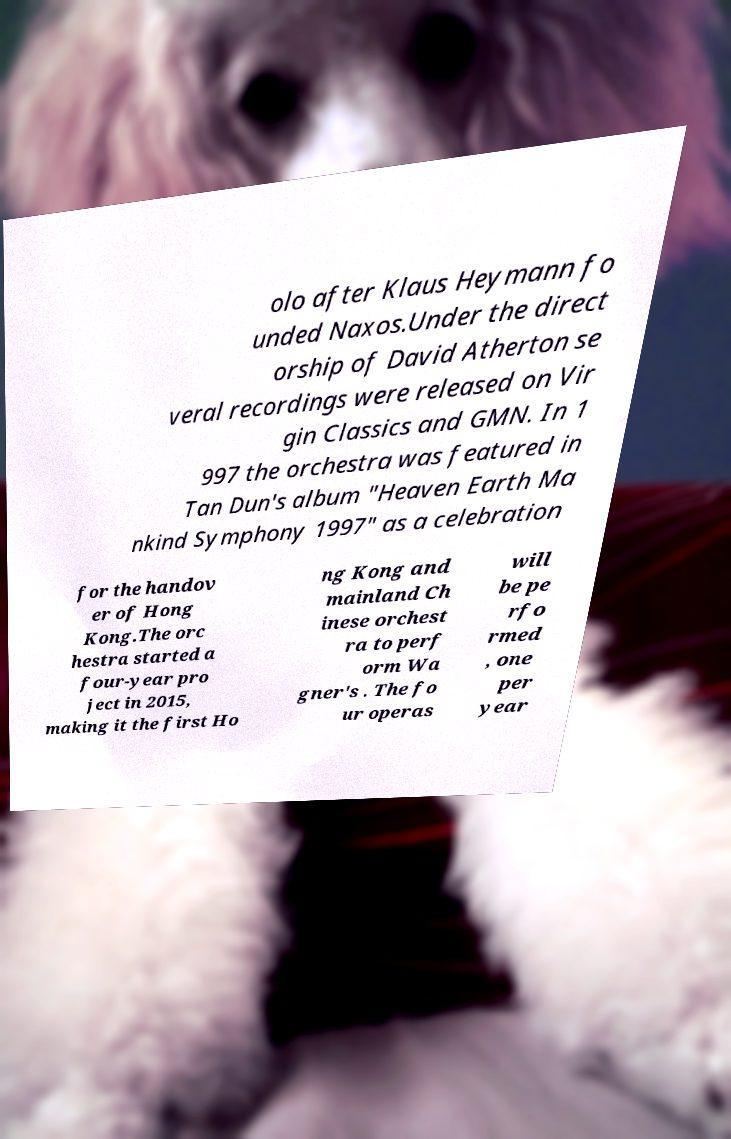Could you assist in decoding the text presented in this image and type it out clearly? olo after Klaus Heymann fo unded Naxos.Under the direct orship of David Atherton se veral recordings were released on Vir gin Classics and GMN. In 1 997 the orchestra was featured in Tan Dun's album "Heaven Earth Ma nkind Symphony 1997" as a celebration for the handov er of Hong Kong.The orc hestra started a four-year pro ject in 2015, making it the first Ho ng Kong and mainland Ch inese orchest ra to perf orm Wa gner's . The fo ur operas will be pe rfo rmed , one per year 